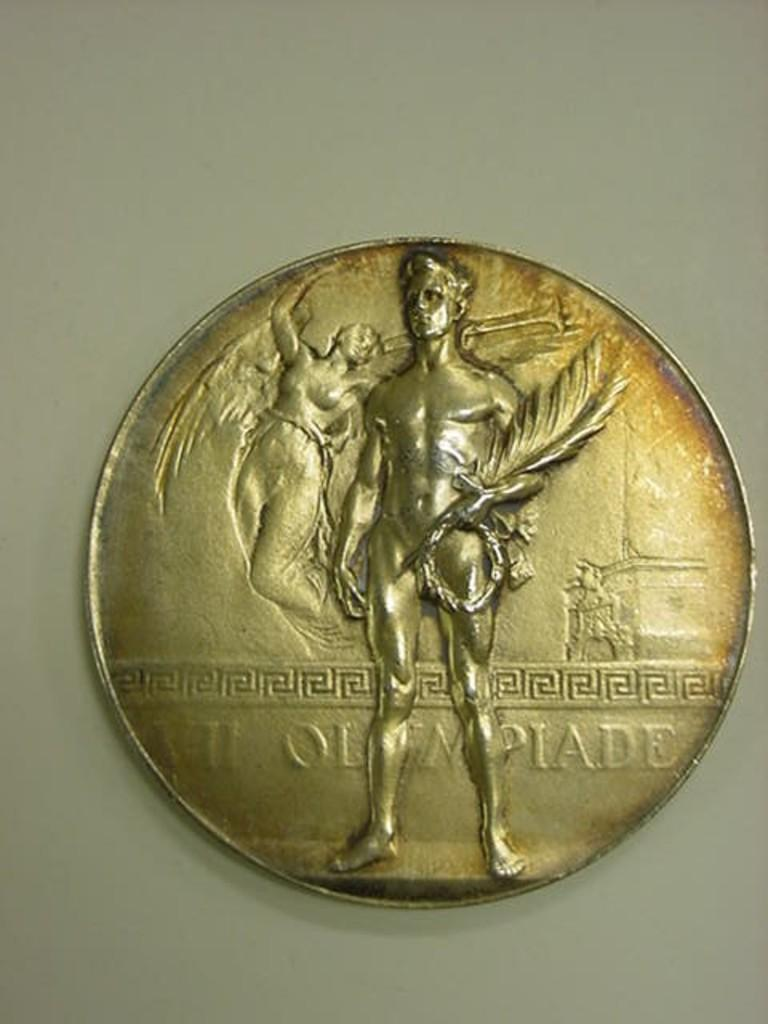Provide a one-sentence caption for the provided image. A gold colored coin has the world Olympiade stamped on it,. 